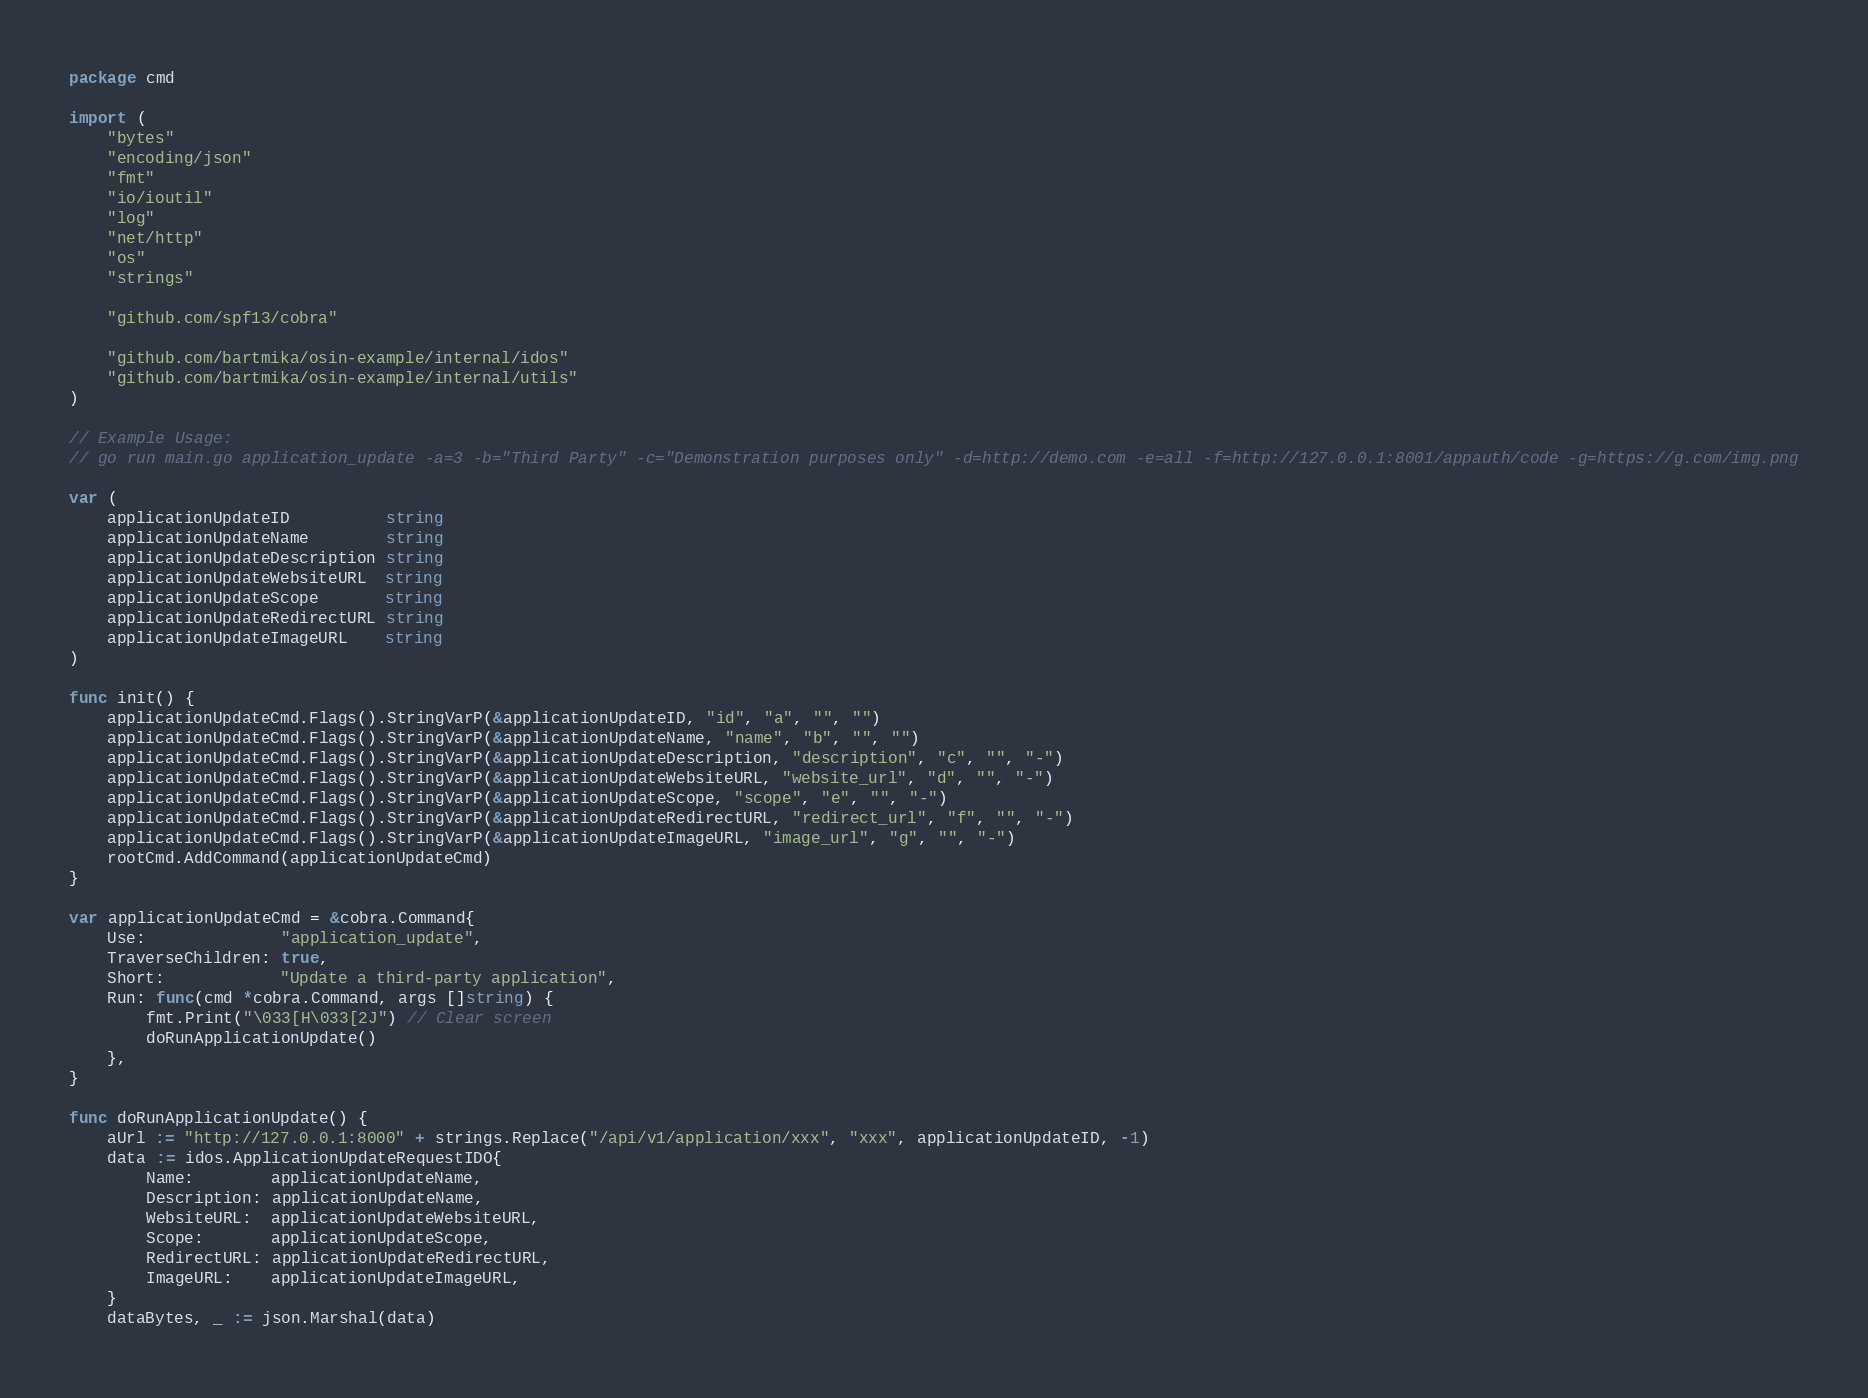<code> <loc_0><loc_0><loc_500><loc_500><_Go_>package cmd

import (
	"bytes"
	"encoding/json"
	"fmt"
	"io/ioutil"
	"log"
	"net/http"
	"os"
	"strings"

	"github.com/spf13/cobra"

	"github.com/bartmika/osin-example/internal/idos"
	"github.com/bartmika/osin-example/internal/utils"
)

// Example Usage:
// go run main.go application_update -a=3 -b="Third Party" -c="Demonstration purposes only" -d=http://demo.com -e=all -f=http://127.0.0.1:8001/appauth/code -g=https://g.com/img.png

var (
	applicationUpdateID          string
	applicationUpdateName        string
	applicationUpdateDescription string
	applicationUpdateWebsiteURL  string
	applicationUpdateScope       string
	applicationUpdateRedirectURL string
	applicationUpdateImageURL    string
)

func init() {
	applicationUpdateCmd.Flags().StringVarP(&applicationUpdateID, "id", "a", "", "")
	applicationUpdateCmd.Flags().StringVarP(&applicationUpdateName, "name", "b", "", "")
	applicationUpdateCmd.Flags().StringVarP(&applicationUpdateDescription, "description", "c", "", "-")
	applicationUpdateCmd.Flags().StringVarP(&applicationUpdateWebsiteURL, "website_url", "d", "", "-")
	applicationUpdateCmd.Flags().StringVarP(&applicationUpdateScope, "scope", "e", "", "-")
	applicationUpdateCmd.Flags().StringVarP(&applicationUpdateRedirectURL, "redirect_url", "f", "", "-")
	applicationUpdateCmd.Flags().StringVarP(&applicationUpdateImageURL, "image_url", "g", "", "-")
	rootCmd.AddCommand(applicationUpdateCmd)
}

var applicationUpdateCmd = &cobra.Command{
	Use:              "application_update",
	TraverseChildren: true,
	Short:            "Update a third-party application",
	Run: func(cmd *cobra.Command, args []string) {
		fmt.Print("\033[H\033[2J") // Clear screen
		doRunApplicationUpdate()
	},
}

func doRunApplicationUpdate() {
	aUrl := "http://127.0.0.1:8000" + strings.Replace("/api/v1/application/xxx", "xxx", applicationUpdateID, -1)
	data := idos.ApplicationUpdateRequestIDO{
		Name:        applicationUpdateName,
		Description: applicationUpdateName,
		WebsiteURL:  applicationUpdateWebsiteURL,
		Scope:       applicationUpdateScope,
		RedirectURL: applicationUpdateRedirectURL,
		ImageURL:    applicationUpdateImageURL,
	}
	dataBytes, _ := json.Marshal(data)</code> 